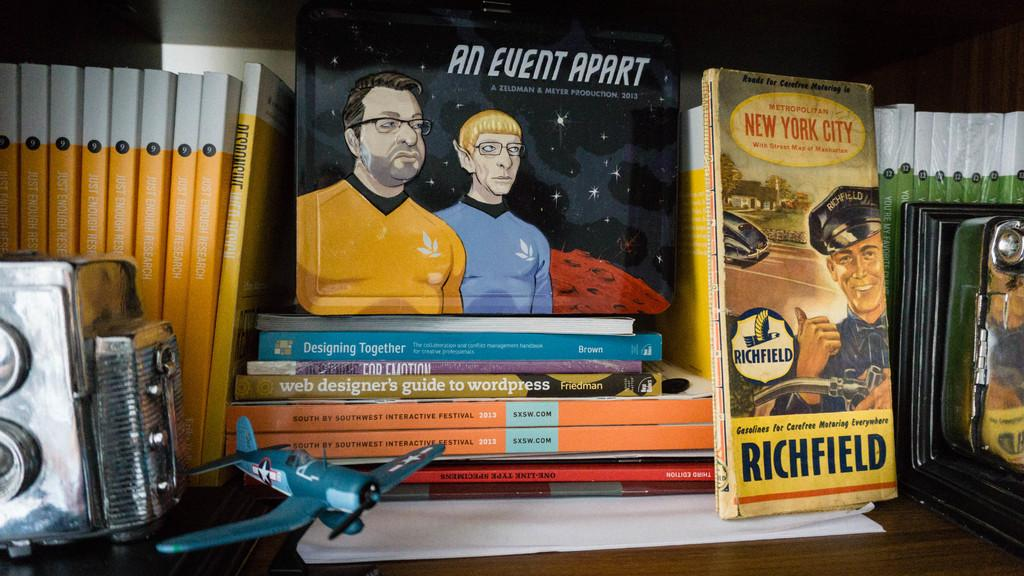<image>
Create a compact narrative representing the image presented. A Star Trek book called An Event Apart sits atop a stack of other books 